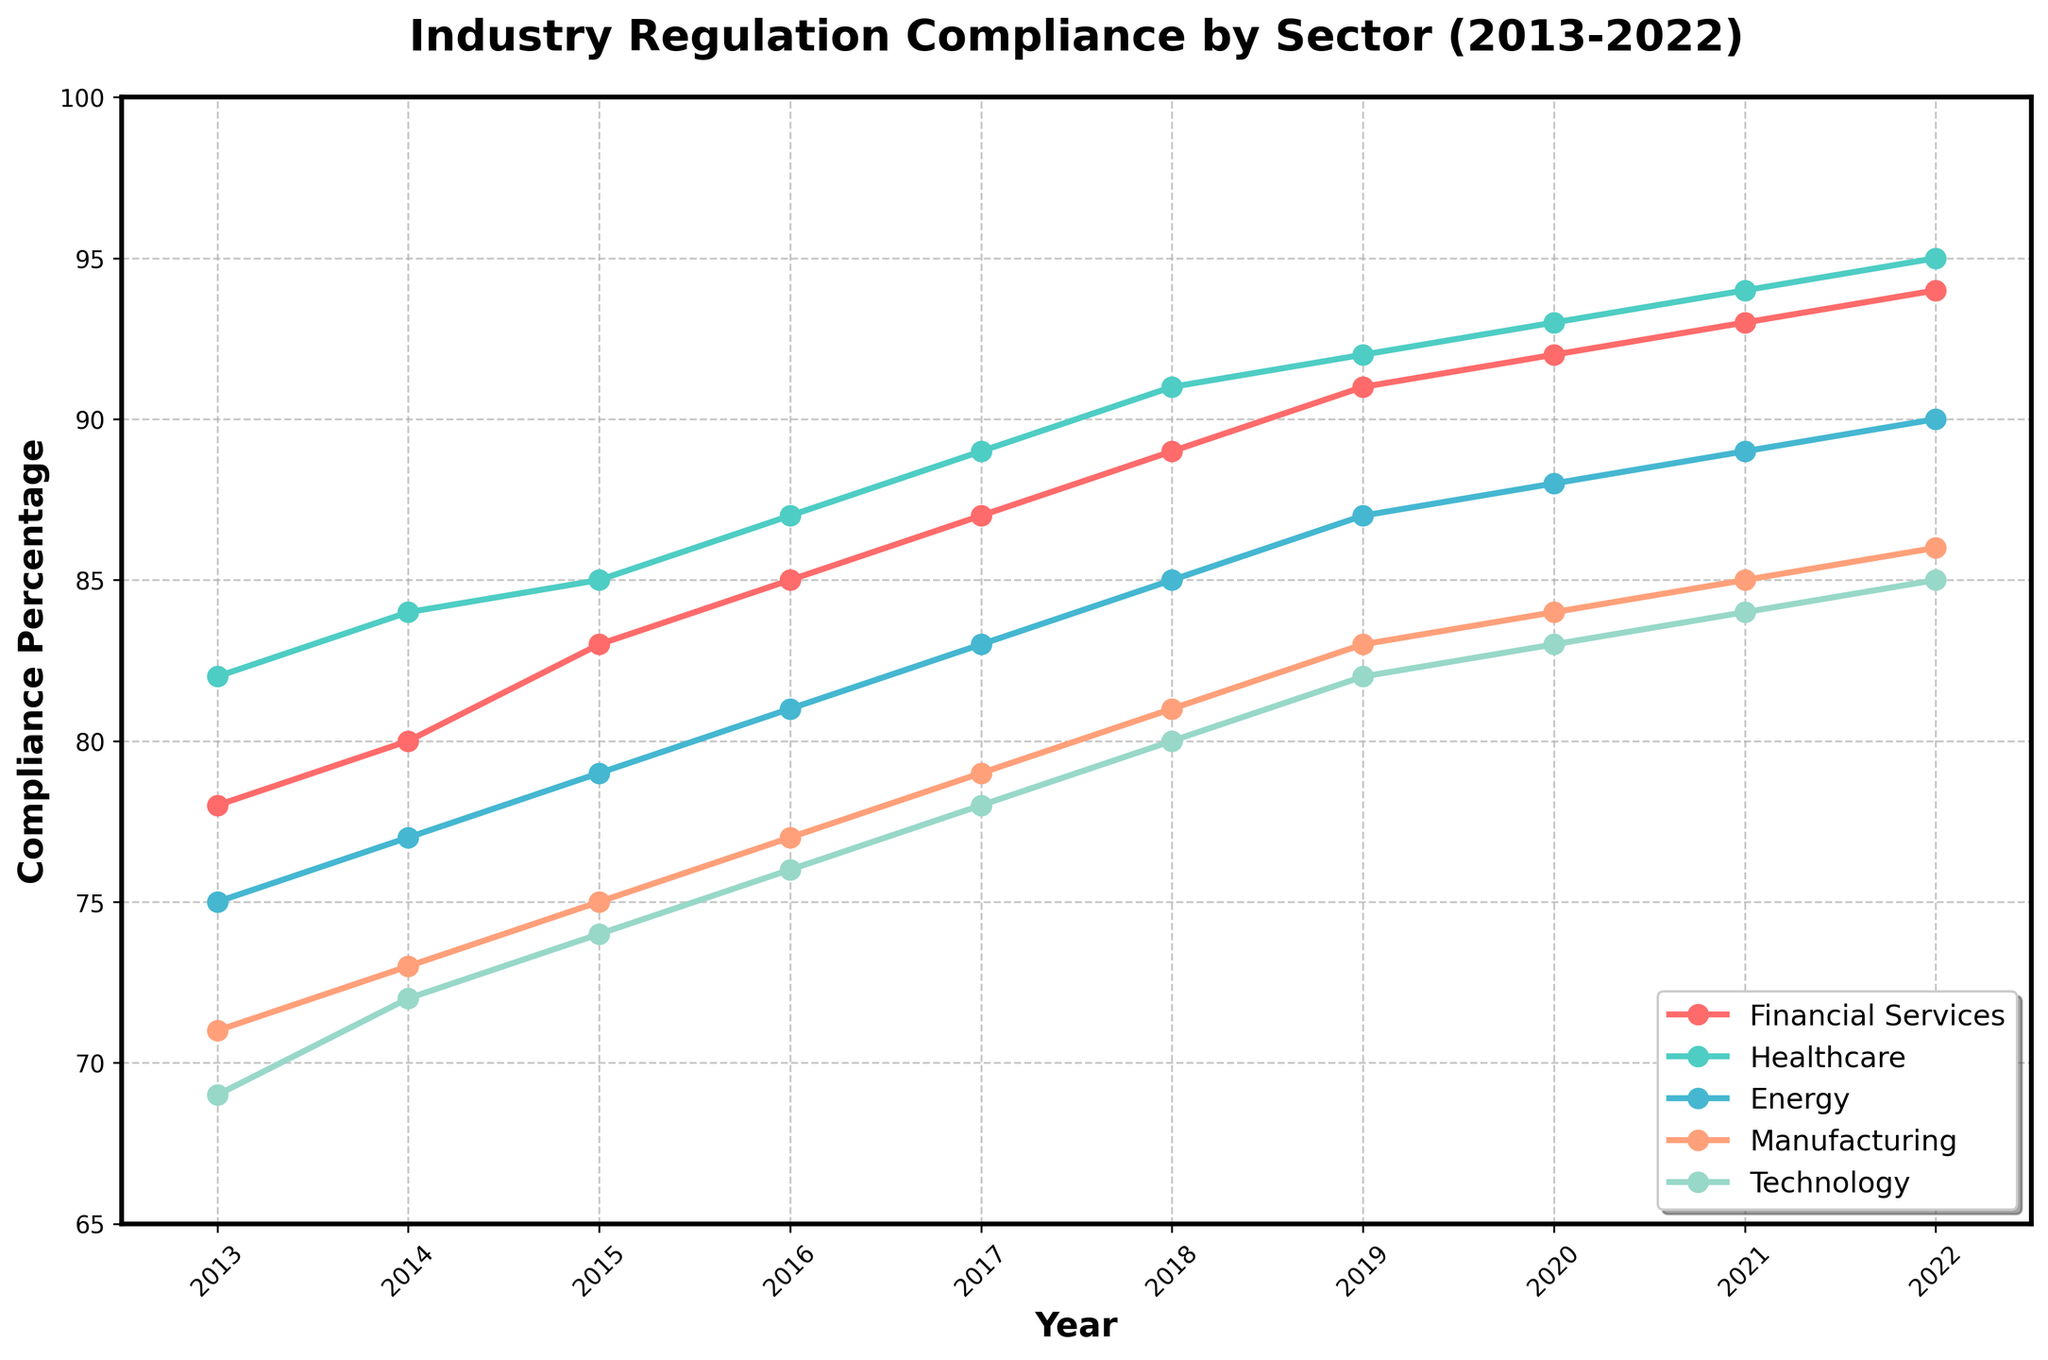What's the overall trend for compliance in the Technology sector from 2013 to 2022? The compliance percentage in the Technology sector starts at 69% in 2013 and steadily increases to 85% by 2022, indicating a consistent upward trend.
Answer: Upward trend In which year does the Healthcare sector first surpass a 90% compliance rate? The Healthcare sector reaches 91% compliance in 2018, which is the first year it surpasses the 90% mark.
Answer: 2018 Compare the compliance rates for Financial Services and Manufacturing sectors in 2015. Which sector had a higher compliance rate, and by how much? In 2015, the Financial Services sector had an 83% compliance rate, while Manufacturing had 75%. The Financial Services sector had a higher rate by 8%.
Answer: Financial Services by 8% Which sector shows the highest compliance improvement from 2013 to 2022, and what is the total increase in compliance percentage for that sector? The Technology sector improves from 69% in 2013 to 85% in 2022, resulting in a total increase of 16% (85 - 69).
Answer: Technology, 16% In 2021, which sector had the lowest compliance rate and what is that rate? In 2021, the Manufacturing sector had the lowest compliance rate at 85%.
Answer: Manufacturing, 85% What is the average compliance rate for the Energy sector over the decade? Adding compliance rates from 2013 to 2022 (75, 77, 79, 81, 83, 85, 87, 88, 89, 90) gives a total of 834. Dividing by 10, the average rate for the Energy sector is 83.4%.
Answer: 83.4% Did the Manufacturing sector ever have a compliance rate higher than Financial Services at any point during the decade? No, the Manufacturing sector never had a compliance rate higher than Financial Services during the entire decade, as Financial Services consistently maintained a higher rate.
Answer: No What year does the Financial Services sector reach a 90% compliance rate, and how does this compare to the Technology sector in the same year? The Financial Services sector reaches 90% compliance in 2020, while the Technology sector has an 83% compliance rate in the same year.
Answer: 2020, Financial Services 90%, Technology 83% How much did the compliance rate for the Healthcare sector increase from 2013 to 2015? The compliance rate for Healthcare increased from 82% in 2013 to 85% in 2015, an increase of 3% (85 - 82).
Answer: 3% Which sector had the smallest absolute increase in compliance rate from 2016 to 2018, and what was the increase? The Manufacturing sector had the smallest increase in compliance rate from 77% in 2016 to 81% in 2018, which is a 4% increase.
Answer: Manufacturing, 4% 